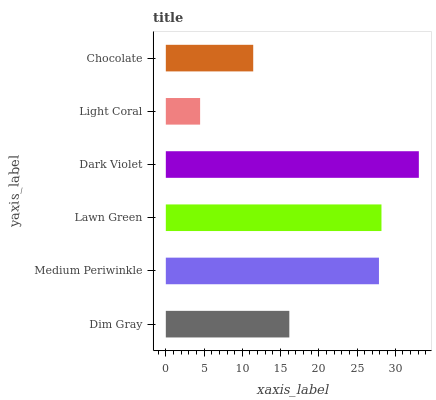Is Light Coral the minimum?
Answer yes or no. Yes. Is Dark Violet the maximum?
Answer yes or no. Yes. Is Medium Periwinkle the minimum?
Answer yes or no. No. Is Medium Periwinkle the maximum?
Answer yes or no. No. Is Medium Periwinkle greater than Dim Gray?
Answer yes or no. Yes. Is Dim Gray less than Medium Periwinkle?
Answer yes or no. Yes. Is Dim Gray greater than Medium Periwinkle?
Answer yes or no. No. Is Medium Periwinkle less than Dim Gray?
Answer yes or no. No. Is Medium Periwinkle the high median?
Answer yes or no. Yes. Is Dim Gray the low median?
Answer yes or no. Yes. Is Dim Gray the high median?
Answer yes or no. No. Is Light Coral the low median?
Answer yes or no. No. 